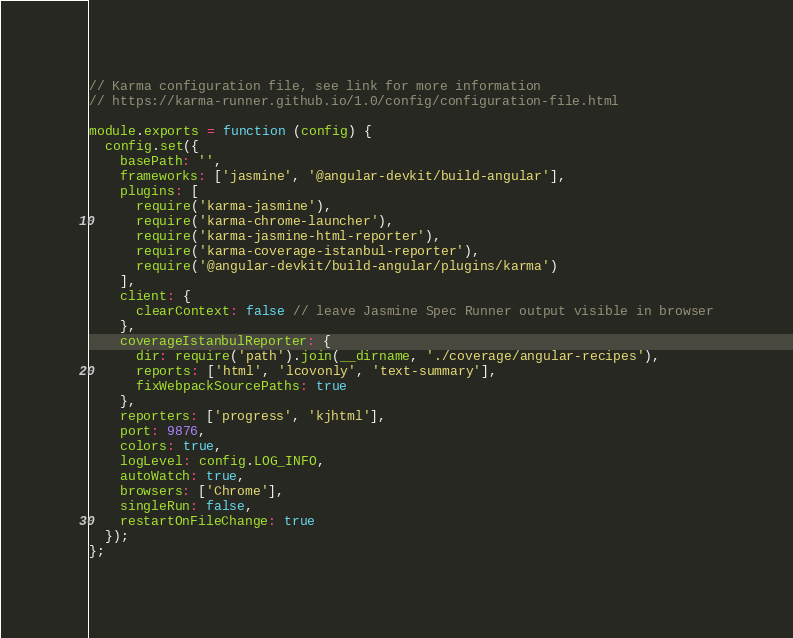<code> <loc_0><loc_0><loc_500><loc_500><_JavaScript_>// Karma configuration file, see link for more information
// https://karma-runner.github.io/1.0/config/configuration-file.html

module.exports = function (config) {
  config.set({
    basePath: '',
    frameworks: ['jasmine', '@angular-devkit/build-angular'],
    plugins: [
      require('karma-jasmine'),
      require('karma-chrome-launcher'),
      require('karma-jasmine-html-reporter'),
      require('karma-coverage-istanbul-reporter'),
      require('@angular-devkit/build-angular/plugins/karma')
    ],
    client: {
      clearContext: false // leave Jasmine Spec Runner output visible in browser
    },
    coverageIstanbulReporter: {
      dir: require('path').join(__dirname, './coverage/angular-recipes'),
      reports: ['html', 'lcovonly', 'text-summary'],
      fixWebpackSourcePaths: true
    },
    reporters: ['progress', 'kjhtml'],
    port: 9876,
    colors: true,
    logLevel: config.LOG_INFO,
    autoWatch: true,
    browsers: ['Chrome'],
    singleRun: false,
    restartOnFileChange: true
  });
};
</code> 